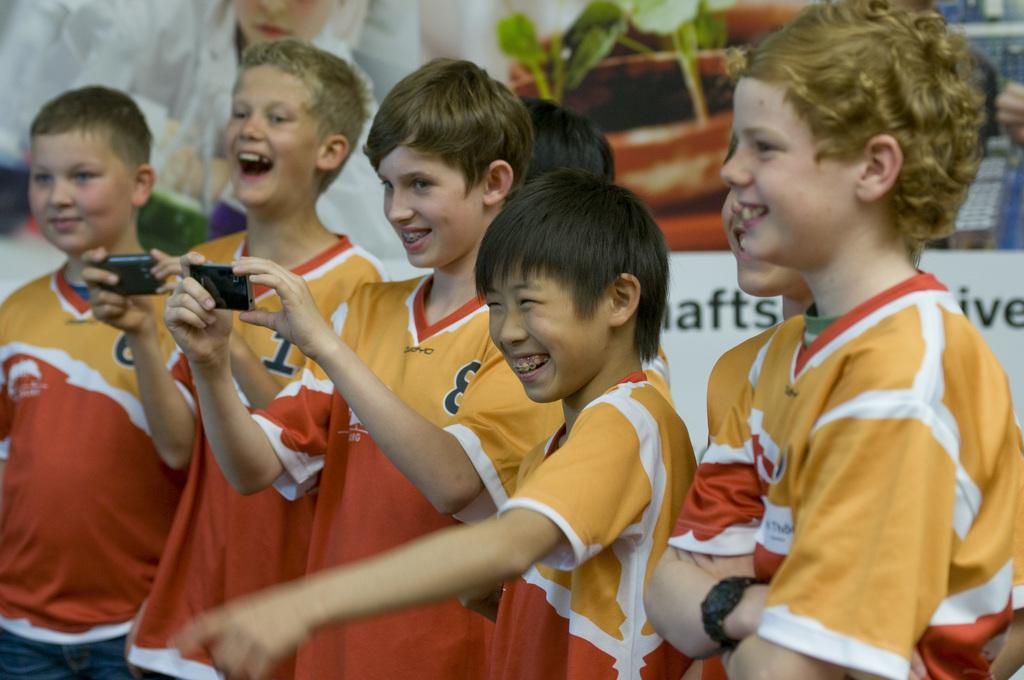Provide a one-sentence caption for the provided image. A group of boys laugh as a boy with the 8 jersey takes a picture. 